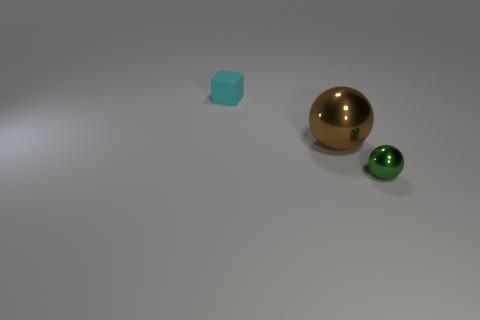There is a metallic object that is left of the green sphere; does it have the same shape as the matte object?
Your answer should be compact. No. What number of other objects are there of the same shape as the rubber object?
Ensure brevity in your answer.  0. What is the shape of the small object in front of the rubber thing?
Keep it short and to the point. Sphere. Is there a green object that has the same material as the tiny sphere?
Keep it short and to the point. No. The brown thing has what size?
Offer a very short reply. Large. Is there a brown ball that is on the right side of the small thing that is behind the tiny object right of the small block?
Your answer should be very brief. Yes. There is a brown thing; what number of cyan matte blocks are on the left side of it?
Your response must be concise. 1. What number of objects are things in front of the cyan block or things that are to the left of the brown sphere?
Keep it short and to the point. 3. Are there more large metal balls than tiny red metallic blocks?
Offer a very short reply. Yes. There is a thing that is to the left of the brown thing; what color is it?
Provide a succinct answer. Cyan. 